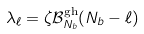<formula> <loc_0><loc_0><loc_500><loc_500>\lambda _ { \ell } = \zeta \mathcal { B } _ { N _ { b } } ^ { \text {gh} } ( N _ { b } - \ell )</formula> 